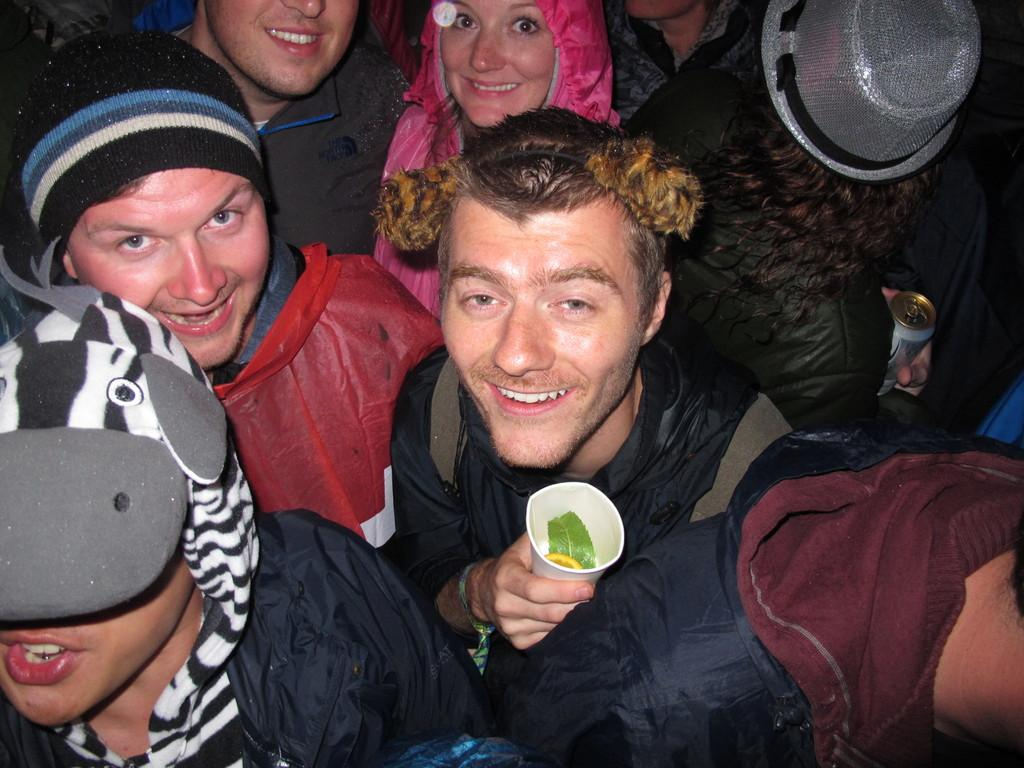How many people are in the image? There are multiple persons in the image. What are the persons wearing in the image? The persons are wearing sweaters, and some of them are wearing caps. What are the persons doing in the image? The persons are standing and posing for a photograph. What type of cushion can be seen supporting the bone in the image? There is no cushion or bone present in the image; it features multiple persons wearing sweaters and caps, standing and posing for a photograph. 